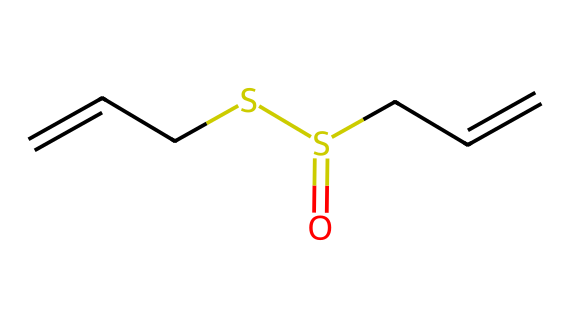What is the molecular formula of allicin? To derive the molecular formula from the SMILES representation, count all the carbon (C), hydrogen (H), sulfur (S), and oxygen (O) atoms. The structure shows 6 carbon atoms, 10 hydrogen atoms, 2 sulfur atoms, and 1 oxygen atom, leading to a molecular formula of C6H10O1S2.
Answer: C6H10O1S2 How many double bonds are present in the structure of allicin? In the SMILES representation, the presence of '=' indicates double bonds. There are two instances of double bonds indicated by "/C=C/", leading to a total of 2 double bonds in the compound.
Answer: 2 What functional group is present in allicin? Examining the SMILES representation, the part "O=S" indicates the presence of a sulfonyl (or sulfinyl) functional group, which is characteristic of organosulfur compounds.
Answer: sulfonyl What feature makes allicin an organosulfur compound? The defining feature of organosulfur compounds is the presence of sulfur atoms (S) in the molecular structure. This compound has two sulfur atoms in its structure, confirming its classification as an organosulfur compound.
Answer: sulfur atoms What is the significance of the double bonds in allicin? Double bonds (represented by "=" in the structure) can affect the reactivity and stability of the compound. They increase the reactivity, allowing allicin to interact with biological molecules, which is crucial for its health benefits.
Answer: reactivity How does the sulfur content influence allicin's biological activity? The sulfur atoms in allicin are responsible for its distinct odor and biological activity, including antioxidant effects and potential health benefits. This unique reactivity is a hallmark of many organosulfur compounds.
Answer: biological activity 